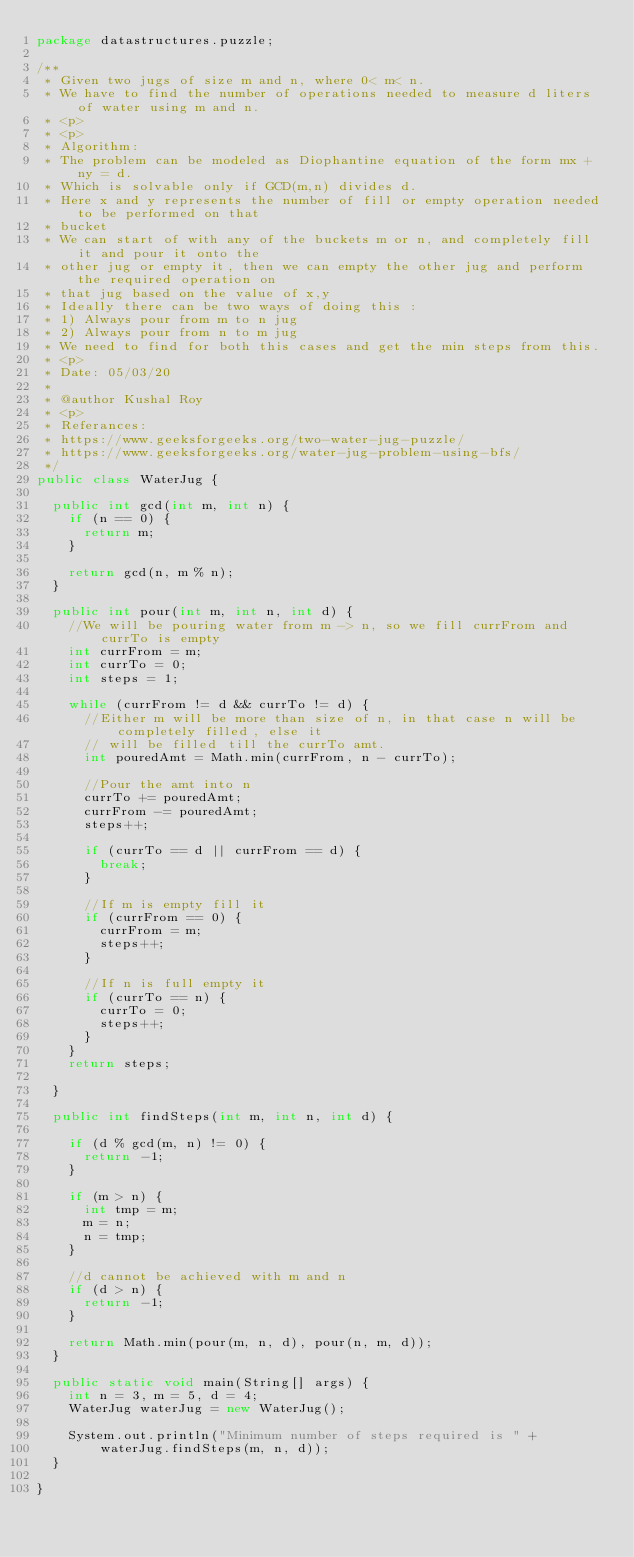<code> <loc_0><loc_0><loc_500><loc_500><_Java_>package datastructures.puzzle;

/**
 * Given two jugs of size m and n, where 0< m< n.
 * We have to find the number of operations needed to measure d liters of water using m and n.
 * <p>
 * <p>
 * Algorithm:
 * The problem can be modeled as Diophantine equation of the form mx + ny = d.
 * Which is solvable only if GCD(m,n) divides d.
 * Here x and y represents the number of fill or empty operation needed to be performed on that
 * bucket
 * We can start of with any of the buckets m or n, and completely fill it and pour it onto the
 * other jug or empty it, then we can empty the other jug and perform the required operation on
 * that jug based on the value of x,y
 * Ideally there can be two ways of doing this :
 * 1) Always pour from m to n jug
 * 2) Always pour from n to m jug
 * We need to find for both this cases and get the min steps from this.
 * <p>
 * Date: 05/03/20
 *
 * @author Kushal Roy
 * <p>
 * Referances:
 * https://www.geeksforgeeks.org/two-water-jug-puzzle/
 * https://www.geeksforgeeks.org/water-jug-problem-using-bfs/
 */
public class WaterJug {

  public int gcd(int m, int n) {
    if (n == 0) {
      return m;
    }

    return gcd(n, m % n);
  }

  public int pour(int m, int n, int d) {
    //We will be pouring water from m -> n, so we fill currFrom and currTo is empty
    int currFrom = m;
    int currTo = 0;
    int steps = 1;

    while (currFrom != d && currTo != d) {
      //Either m will be more than size of n, in that case n will be completely filled, else it
      // will be filled till the currTo amt.
      int pouredAmt = Math.min(currFrom, n - currTo);

      //Pour the amt into n
      currTo += pouredAmt;
      currFrom -= pouredAmt;
      steps++;

      if (currTo == d || currFrom == d) {
        break;
      }

      //If m is empty fill it
      if (currFrom == 0) {
        currFrom = m;
        steps++;
      }

      //If n is full empty it
      if (currTo == n) {
        currTo = 0;
        steps++;
      }
    }
    return steps;

  }

  public int findSteps(int m, int n, int d) {

    if (d % gcd(m, n) != 0) {
      return -1;
    }

    if (m > n) {
      int tmp = m;
      m = n;
      n = tmp;
    }

    //d cannot be achieved with m and n
    if (d > n) {
      return -1;
    }

    return Math.min(pour(m, n, d), pour(n, m, d));
  }

  public static void main(String[] args) {
    int n = 3, m = 5, d = 4;
    WaterJug waterJug = new WaterJug();

    System.out.println("Minimum number of steps required is " +
        waterJug.findSteps(m, n, d));
  }

}
</code> 